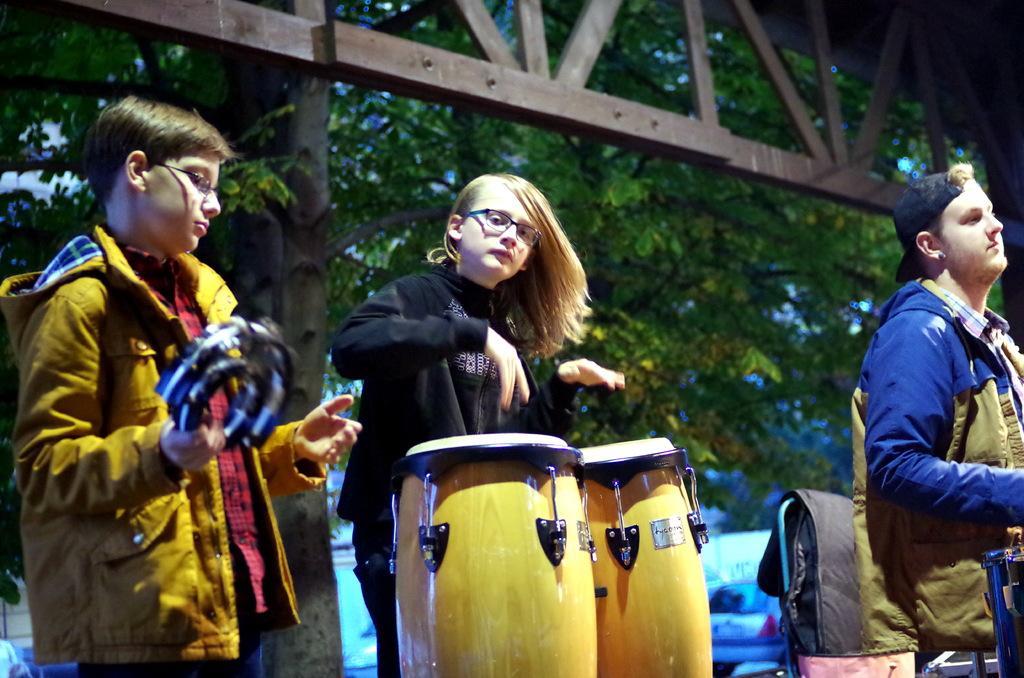In one or two sentences, can you explain what this image depicts? In this picture we can see three people are playing musical instruments, in the background we can see couple of trees and cars. 